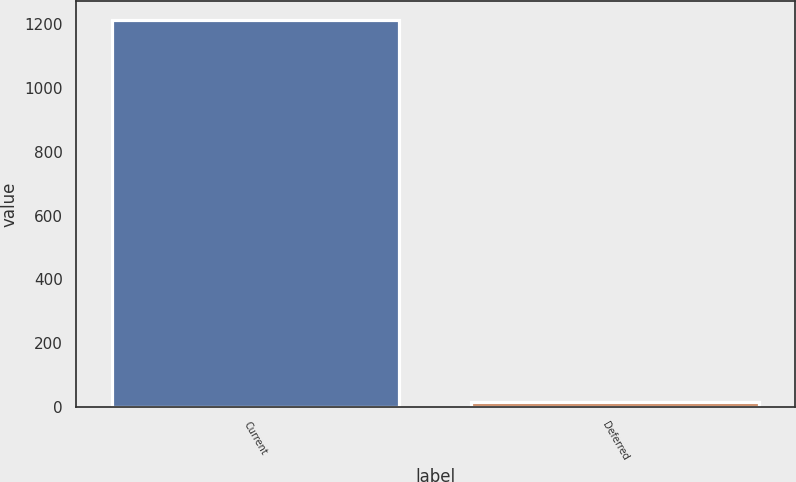<chart> <loc_0><loc_0><loc_500><loc_500><bar_chart><fcel>Current<fcel>Deferred<nl><fcel>1212<fcel>16<nl></chart> 